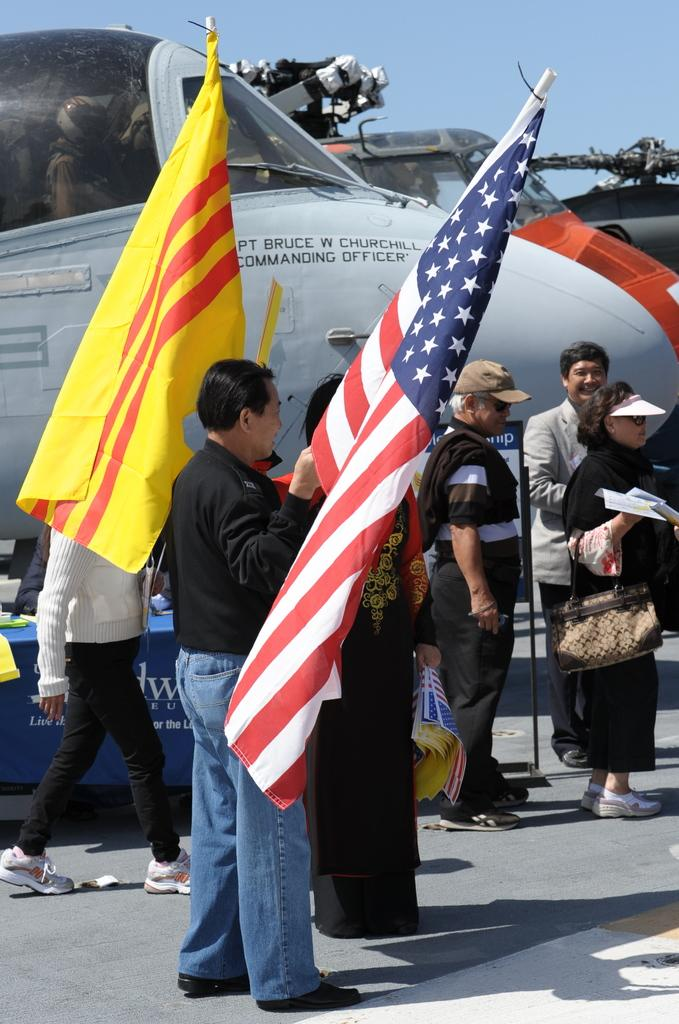Who or what is present in the image? There are people in the image. What are the people holding? The people are holding flags. Where are the people standing? The people are standing on a road. What other vehicles are in the image besides the people? There are aeroplanes and helicopters in the image. What part of the natural environment is visible in the image? The sky is visible in the image. What type of leaf can be seen on the person's lip in the image? There is no leaf or person's lip visible in the image. How does the beggar in the image interact with the people holding flags? There is no beggar present in the image. 